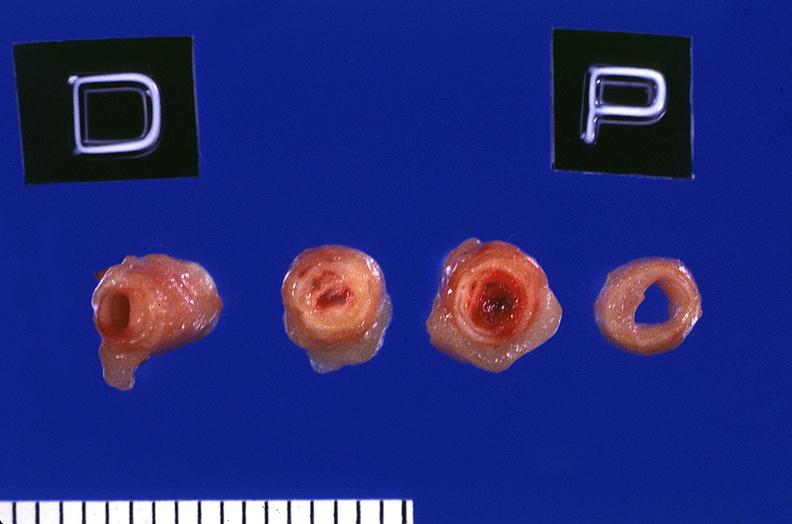what is present?
Answer the question using a single word or phrase. Vasculature 